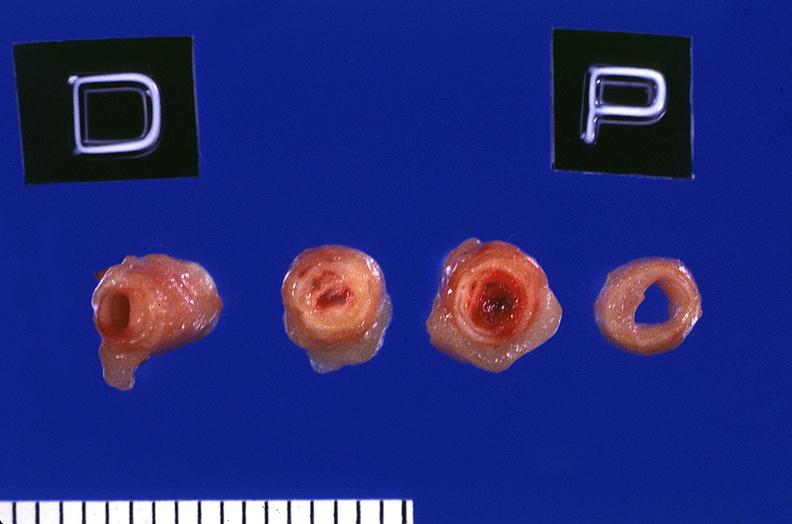what is present?
Answer the question using a single word or phrase. Vasculature 